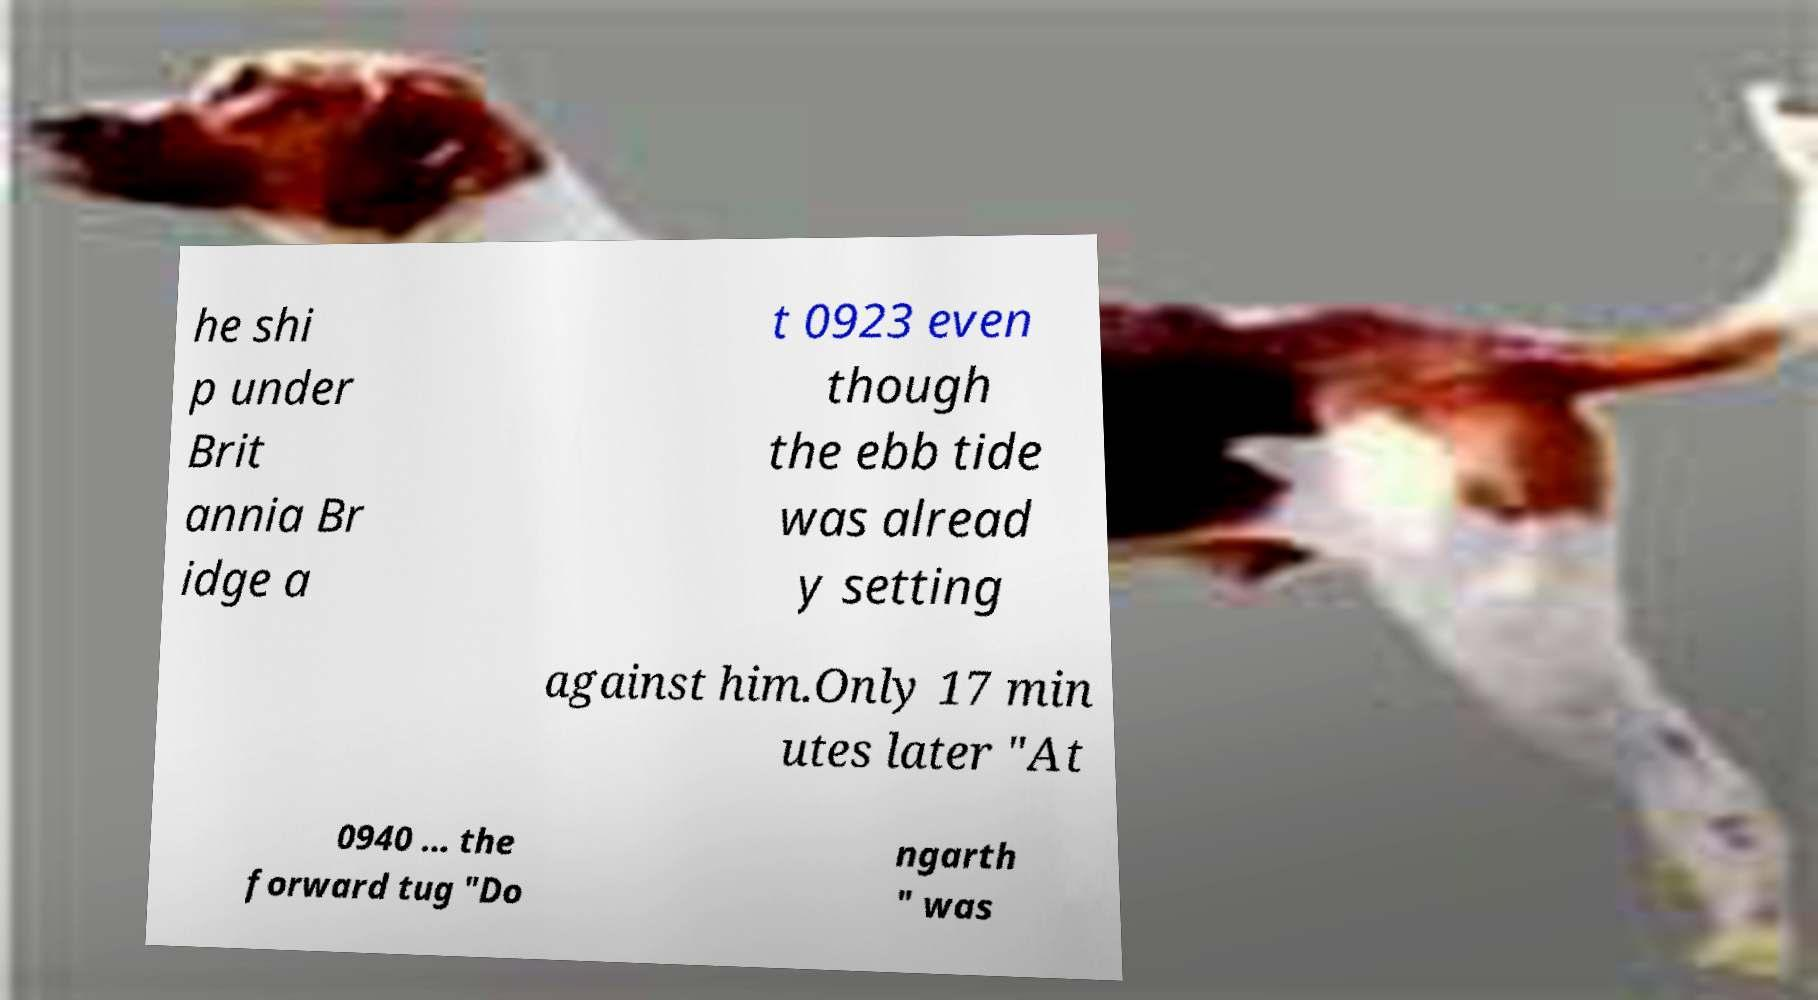Can you accurately transcribe the text from the provided image for me? he shi p under Brit annia Br idge a t 0923 even though the ebb tide was alread y setting against him.Only 17 min utes later "At 0940 ... the forward tug "Do ngarth " was 